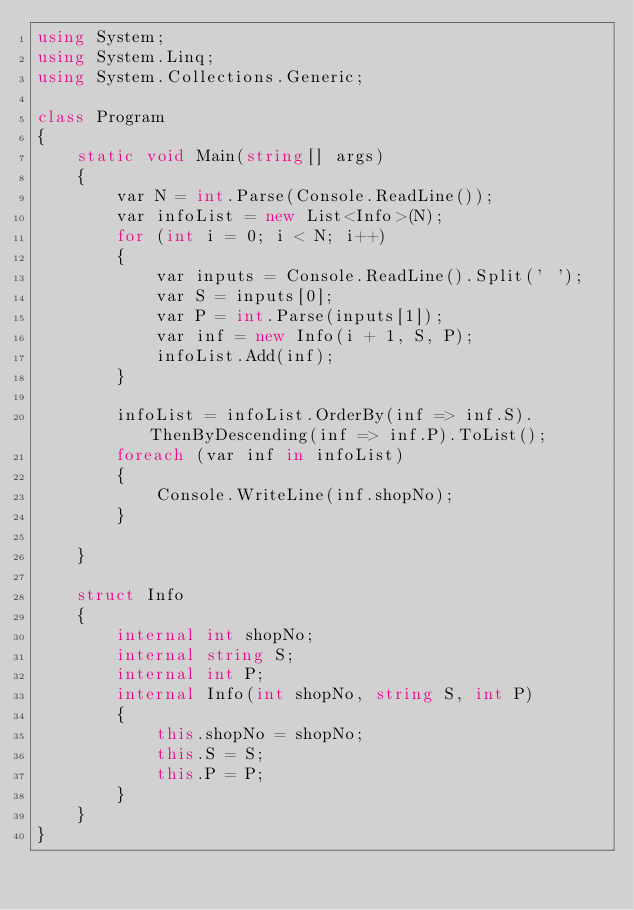<code> <loc_0><loc_0><loc_500><loc_500><_C#_>using System;
using System.Linq;
using System.Collections.Generic;

class Program
{
    static void Main(string[] args)
    {
        var N = int.Parse(Console.ReadLine());
        var infoList = new List<Info>(N);
        for (int i = 0; i < N; i++)
        {
            var inputs = Console.ReadLine().Split(' ');
            var S = inputs[0];
            var P = int.Parse(inputs[1]);
            var inf = new Info(i + 1, S, P);
            infoList.Add(inf);
        }

        infoList = infoList.OrderBy(inf => inf.S).ThenByDescending(inf => inf.P).ToList();
        foreach (var inf in infoList)
        {
            Console.WriteLine(inf.shopNo);
        }

    }

    struct Info
    {
        internal int shopNo;
        internal string S;
        internal int P;
        internal Info(int shopNo, string S, int P)
        {
            this.shopNo = shopNo;
            this.S = S;
            this.P = P;
        }
    }
}

</code> 